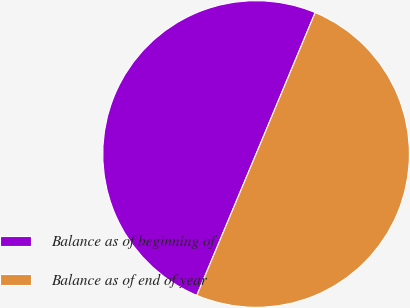Convert chart to OTSL. <chart><loc_0><loc_0><loc_500><loc_500><pie_chart><fcel>Balance as of beginning of<fcel>Balance as of end of year<nl><fcel>49.98%<fcel>50.02%<nl></chart> 